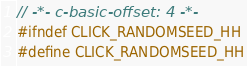Convert code to text. <code><loc_0><loc_0><loc_500><loc_500><_C++_>// -*- c-basic-offset: 4 -*-
#ifndef CLICK_RANDOMSEED_HH
#define CLICK_RANDOMSEED_HH</code> 